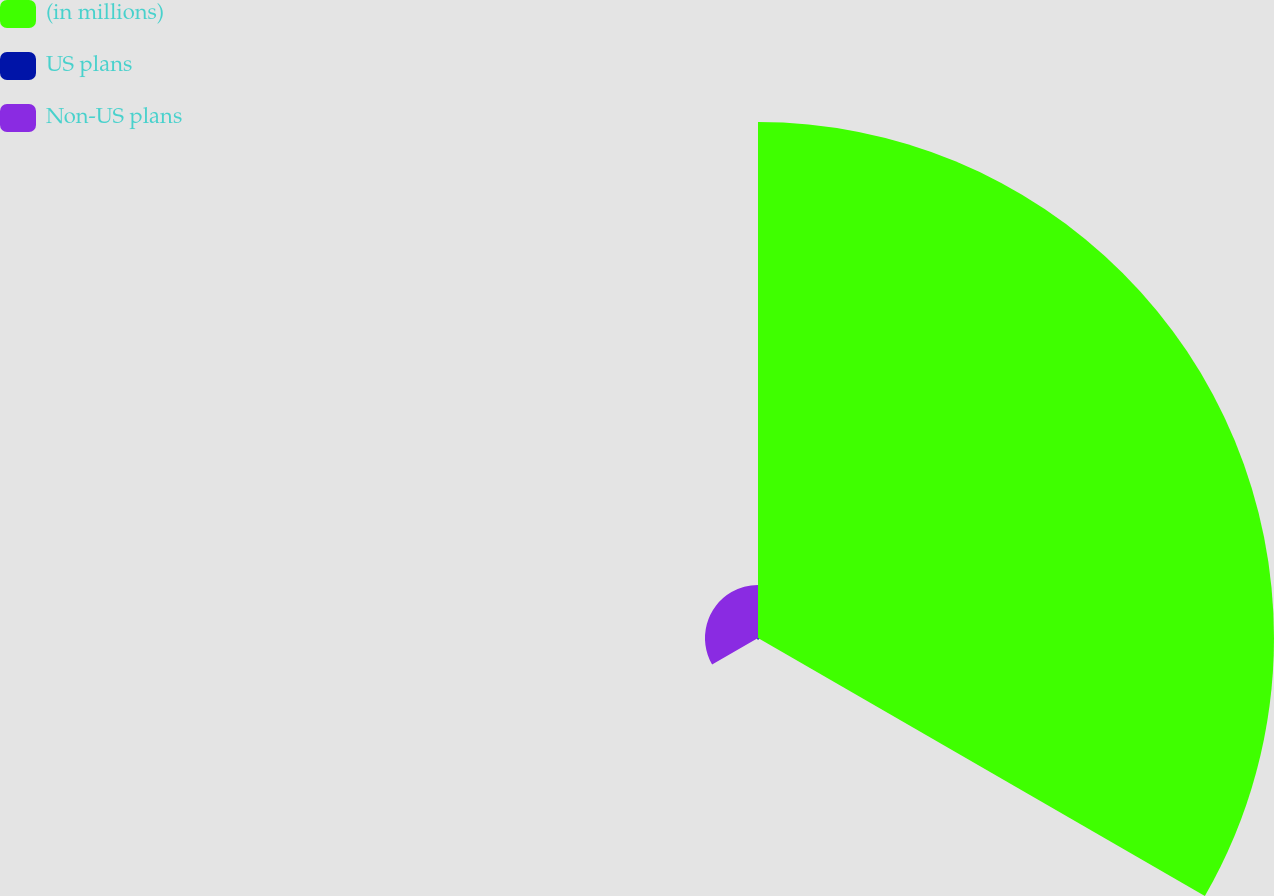Convert chart to OTSL. <chart><loc_0><loc_0><loc_500><loc_500><pie_chart><fcel>(in millions)<fcel>US plans<fcel>Non-US plans<nl><fcel>90.44%<fcel>0.27%<fcel>9.29%<nl></chart> 